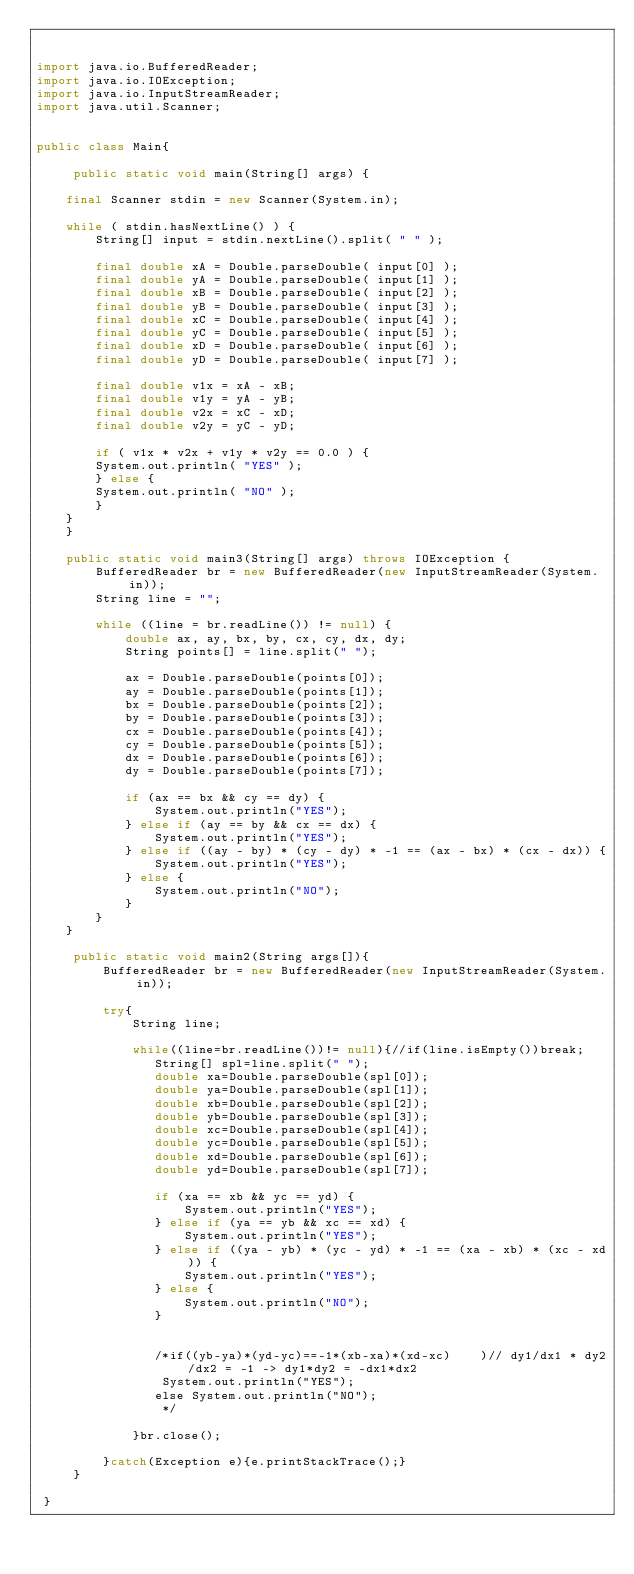<code> <loc_0><loc_0><loc_500><loc_500><_Java_>

import java.io.BufferedReader;
import java.io.IOException;
import java.io.InputStreamReader;
import java.util.Scanner;
 

public class Main{
          
     public static void main(String[] args) {
 
    final Scanner stdin = new Scanner(System.in);
 
    while ( stdin.hasNextLine() ) {
        String[] input = stdin.nextLine().split( " " );
 
        final double xA = Double.parseDouble( input[0] );
        final double yA = Double.parseDouble( input[1] );
        final double xB = Double.parseDouble( input[2] );
        final double yB = Double.parseDouble( input[3] );
        final double xC = Double.parseDouble( input[4] );
        final double yC = Double.parseDouble( input[5] );
        final double xD = Double.parseDouble( input[6] );
        final double yD = Double.parseDouble( input[7] );
 
        final double v1x = xA - xB;
        final double v1y = yA - yB;
        final double v2x = xC - xD;
        final double v2y = yC - yD;
 
        if ( v1x * v2x + v1y * v2y == 0.0 ) {
        System.out.println( "YES" );
        } else {
        System.out.println( "NO" );
        }       
    }   
    } 
    
    public static void main3(String[] args) throws IOException {
        BufferedReader br = new BufferedReader(new InputStreamReader(System.in));
        String line = "";
 
        while ((line = br.readLine()) != null) {
            double ax, ay, bx, by, cx, cy, dx, dy;
            String points[] = line.split(" ");
 
            ax = Double.parseDouble(points[0]);
            ay = Double.parseDouble(points[1]);
            bx = Double.parseDouble(points[2]);
            by = Double.parseDouble(points[3]);
            cx = Double.parseDouble(points[4]);
            cy = Double.parseDouble(points[5]);
            dx = Double.parseDouble(points[6]);
            dy = Double.parseDouble(points[7]);
 
            if (ax == bx && cy == dy) {
                System.out.println("YES");
            } else if (ay == by && cx == dx) {
                System.out.println("YES");
            } else if ((ay - by) * (cy - dy) * -1 == (ax - bx) * (cx - dx)) {
                System.out.println("YES");
            } else {
                System.out.println("NO");
            }
        }
    }
     
     public static void main2(String args[]){
         BufferedReader br = new BufferedReader(new InputStreamReader(System.in));
         
         try{
             String line;
            
             while((line=br.readLine())!= null){//if(line.isEmpty())break;
                String[] spl=line.split(" ");
                double xa=Double.parseDouble(spl[0]);
                double ya=Double.parseDouble(spl[1]);
                double xb=Double.parseDouble(spl[2]);
                double yb=Double.parseDouble(spl[3]);
                double xc=Double.parseDouble(spl[4]);
                double yc=Double.parseDouble(spl[5]);
                double xd=Double.parseDouble(spl[6]);
                double yd=Double.parseDouble(spl[7]);

                if (xa == xb && yc == yd) {
                    System.out.println("YES");
                } else if (ya == yb && xc == xd) {
                    System.out.println("YES");
                } else if ((ya - yb) * (yc - yd) * -1 == (xa - xb) * (xc - xd)) {
                    System.out.println("YES");
                } else {
                    System.out.println("NO");
                }
                
                
                /*if((yb-ya)*(yd-yc)==-1*(xb-xa)*(xd-xc)    )// dy1/dx1 * dy2/dx2 = -1 -> dy1*dy2 = -dx1*dx2
                 System.out.println("YES");
                else System.out.println("NO");
                 */
                
             }br.close();
             
         }catch(Exception e){e.printStackTrace();}         
     }
   
 }</code> 